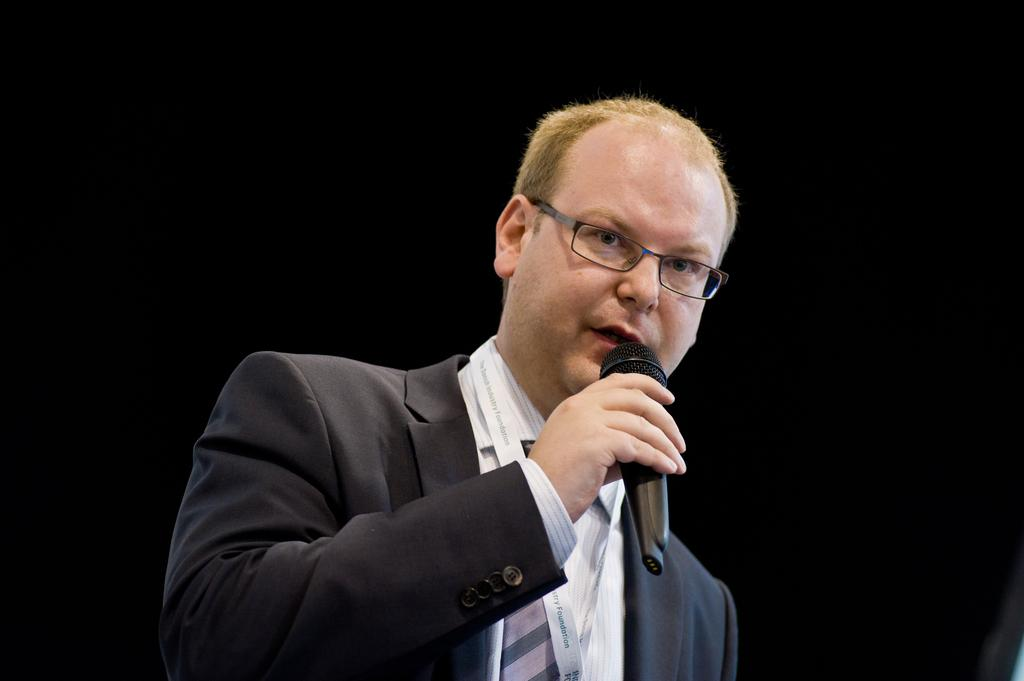What is the main subject of the image? There is a person in the image. Can you describe the background of the image? The background of the image is dark. What is the person wearing in the image? The person is wearing clothes. What is the person holding in their hand? The person is holding a mic in their hand. What type of twig can be seen in the person's hand in the image? There is no twig present in the person's hand in the image; they are holding a mic. 